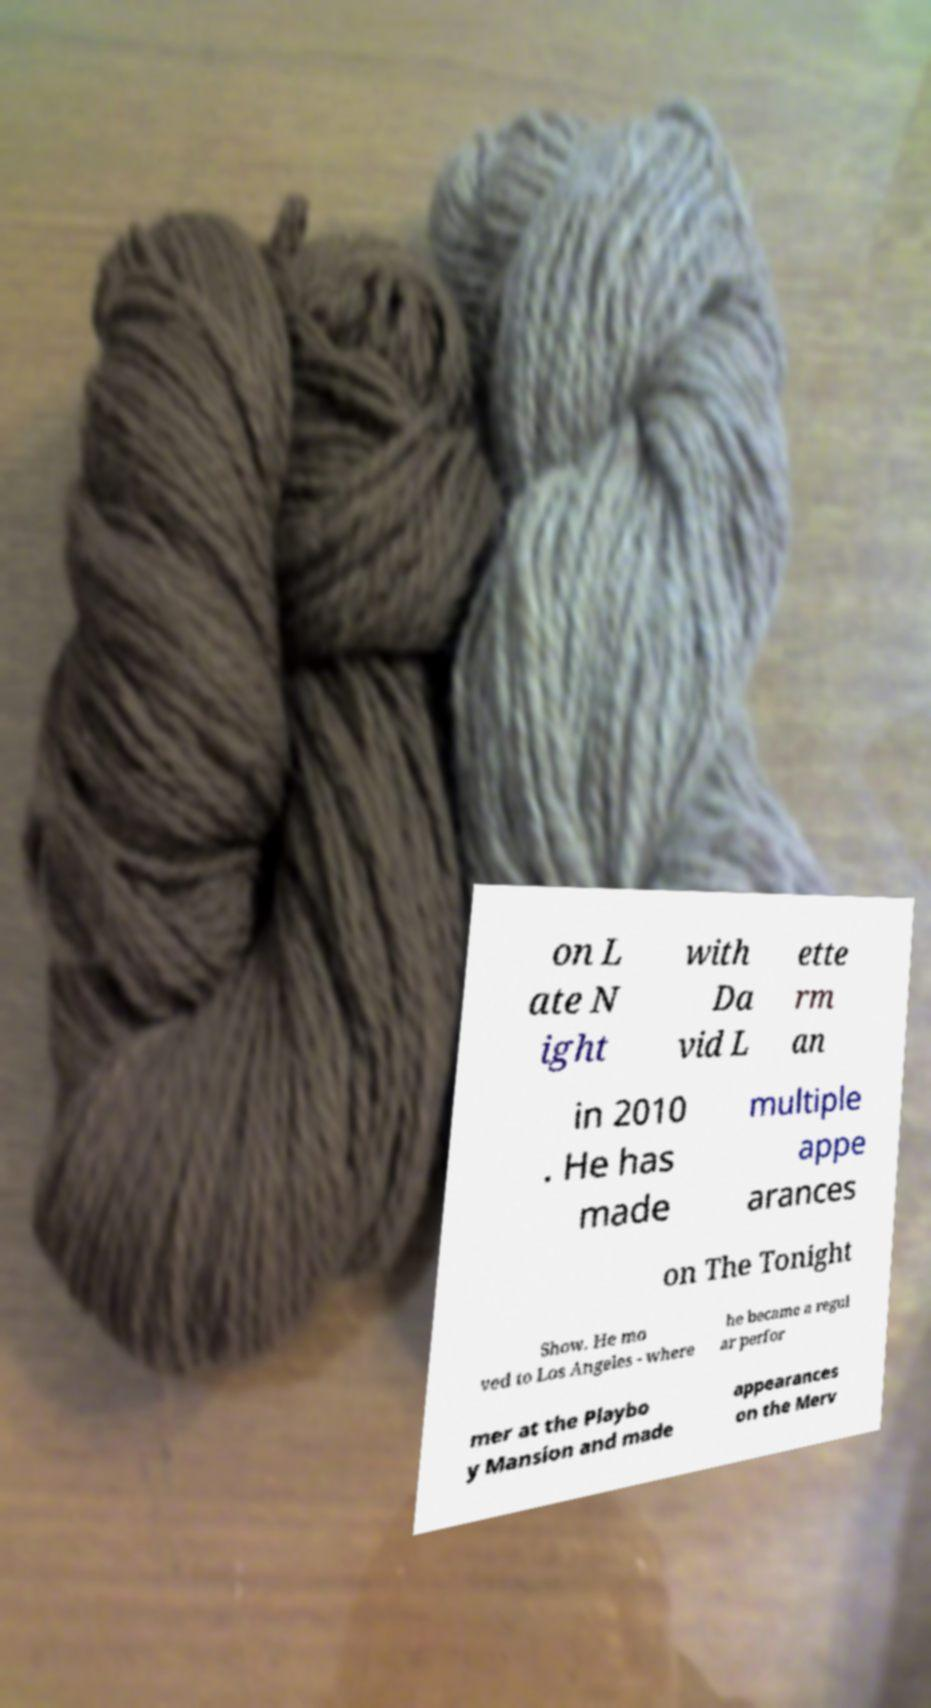Could you assist in decoding the text presented in this image and type it out clearly? on L ate N ight with Da vid L ette rm an in 2010 . He has made multiple appe arances on The Tonight Show. He mo ved to Los Angeles - where he became a regul ar perfor mer at the Playbo y Mansion and made appearances on the Merv 